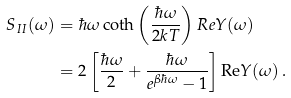<formula> <loc_0><loc_0><loc_500><loc_500>S _ { I I } ( \omega ) & = \hbar { \omega } \coth \left ( \frac { \hbar { \omega } } { 2 k T } \right ) R e Y ( \omega ) \\ & = 2 \left [ \frac { \hbar { \omega } } { 2 } + \frac { \hbar { \omega } } { e ^ { \beta \hbar { \omega } } - 1 } \right ] \text {Re} Y ( \omega ) \, .</formula> 